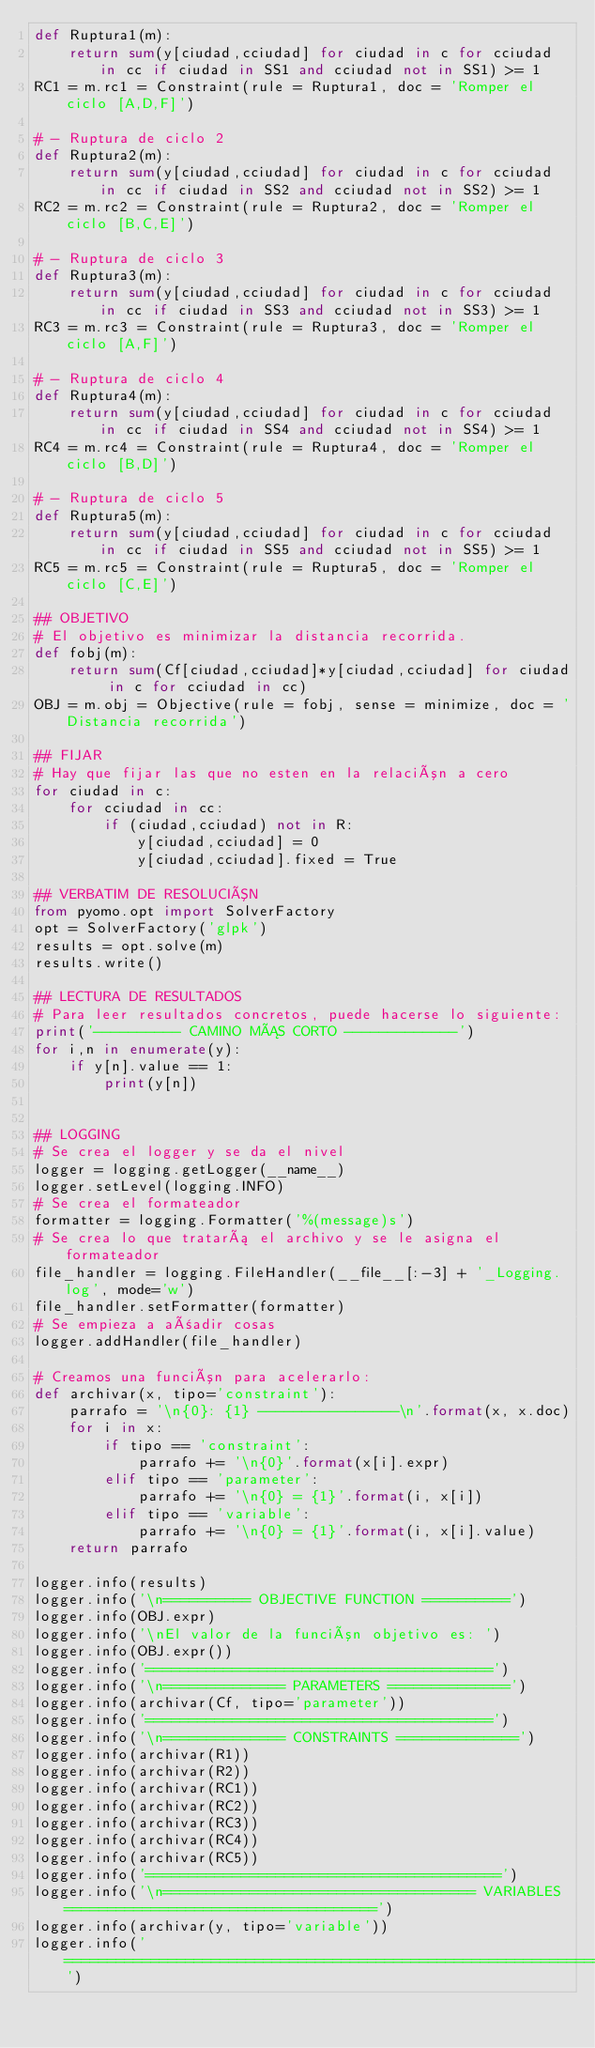Convert code to text. <code><loc_0><loc_0><loc_500><loc_500><_Python_>def Ruptura1(m):
    return sum(y[ciudad,cciudad] for ciudad in c for cciudad in cc if ciudad in SS1 and cciudad not in SS1) >= 1
RC1 = m.rc1 = Constraint(rule = Ruptura1, doc = 'Romper el ciclo [A,D,F]')

# - Ruptura de ciclo 2
def Ruptura2(m):
    return sum(y[ciudad,cciudad] for ciudad in c for cciudad in cc if ciudad in SS2 and cciudad not in SS2) >= 1
RC2 = m.rc2 = Constraint(rule = Ruptura2, doc = 'Romper el ciclo [B,C,E]')

# - Ruptura de ciclo 3
def Ruptura3(m):
    return sum(y[ciudad,cciudad] for ciudad in c for cciudad in cc if ciudad in SS3 and cciudad not in SS3) >= 1
RC3 = m.rc3 = Constraint(rule = Ruptura3, doc = 'Romper el ciclo [A,F]')

# - Ruptura de ciclo 4
def Ruptura4(m):
    return sum(y[ciudad,cciudad] for ciudad in c for cciudad in cc if ciudad in SS4 and cciudad not in SS4) >= 1
RC4 = m.rc4 = Constraint(rule = Ruptura4, doc = 'Romper el ciclo [B,D]')

# - Ruptura de ciclo 5
def Ruptura5(m):
    return sum(y[ciudad,cciudad] for ciudad in c for cciudad in cc if ciudad in SS5 and cciudad not in SS5) >= 1
RC5 = m.rc5 = Constraint(rule = Ruptura5, doc = 'Romper el ciclo [C,E]')

## OBJETIVO
# El objetivo es minimizar la distancia recorrida.
def fobj(m):
    return sum(Cf[ciudad,cciudad]*y[ciudad,cciudad] for ciudad in c for cciudad in cc)
OBJ = m.obj = Objective(rule = fobj, sense = minimize, doc = 'Distancia recorrida')

## FIJAR
# Hay que fijar las que no esten en la relación a cero
for ciudad in c:
    for cciudad in cc:
        if (ciudad,cciudad) not in R:
            y[ciudad,cciudad] = 0
            y[ciudad,cciudad].fixed = True

## VERBATIM DE RESOLUCIÓN
from pyomo.opt import SolverFactory
opt = SolverFactory('glpk')
results = opt.solve(m)
results.write()

## LECTURA DE RESULTADOS
# Para leer resultados concretos, puede hacerse lo siguiente:
print('---------- CAMINO MÁS CORTO -------------')
for i,n in enumerate(y):
    if y[n].value == 1:
        print(y[n])


## LOGGING
# Se crea el logger y se da el nivel
logger = logging.getLogger(__name__)
logger.setLevel(logging.INFO)
# Se crea el formateador
formatter = logging.Formatter('%(message)s')
# Se crea lo que tratará el archivo y se le asigna el formateador
file_handler = logging.FileHandler(__file__[:-3] + '_Logging.log', mode='w')
file_handler.setFormatter(formatter)
# Se empieza a añadir cosas
logger.addHandler(file_handler)

# Creamos una función para acelerarlo:
def archivar(x, tipo='constraint'):
    parrafo = '\n{0}: {1} ----------------\n'.format(x, x.doc)
    for i in x:
        if tipo == 'constraint':
            parrafo += '\n{0}'.format(x[i].expr)
        elif tipo == 'parameter':
            parrafo += '\n{0} = {1}'.format(i, x[i])
        elif tipo == 'variable':
            parrafo += '\n{0} = {1}'.format(i, x[i].value)
    return parrafo

logger.info(results)
logger.info('\n========== OBJECTIVE FUNCTION ==========')
logger.info(OBJ.expr)
logger.info('\nEl valor de la función objetivo es: ')
logger.info(OBJ.expr())
logger.info('========================================')
logger.info('\n============== PARAMETERS ==============')
logger.info(archivar(Cf, tipo='parameter'))
logger.info('========================================')
logger.info('\n============== CONSTRAINTS ==============')
logger.info(archivar(R1))
logger.info(archivar(R2))
logger.info(archivar(RC1))
logger.info(archivar(RC2))
logger.info(archivar(RC3))
logger.info(archivar(RC4))
logger.info(archivar(RC5))
logger.info('=========================================')
logger.info('\n==================================== VARIABLES ====================================')
logger.info(archivar(y, tipo='variable'))
logger.info('===================================================================================')
</code> 